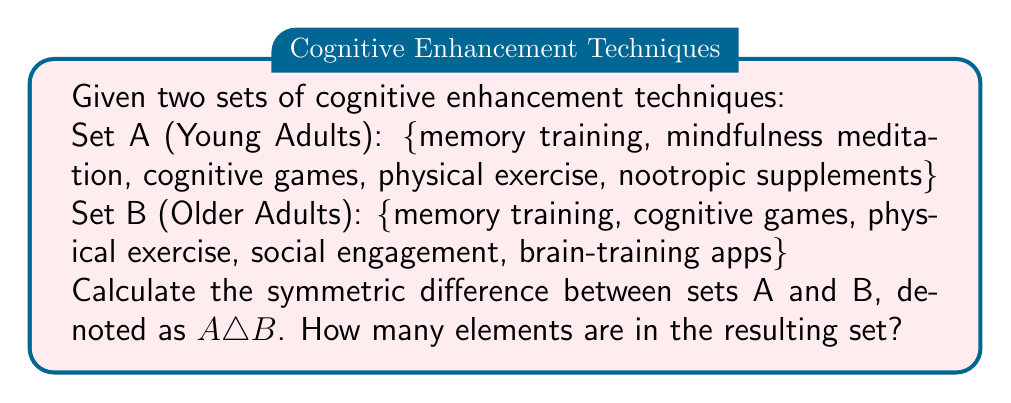Can you answer this question? To solve this problem, we need to follow these steps:

1. Understand the concept of symmetric difference:
   The symmetric difference of two sets A and B, denoted as $A \triangle B$, is the set of elements that are in either A or B, but not in both.

2. Mathematically, we can express this as:
   $A \triangle B = (A \setminus B) \cup (B \setminus A)$
   where $\setminus$ denotes set difference.

3. Identify the elements unique to each set:
   - Elements in A but not in B: {mindfulness meditation, nootropic supplements}
   - Elements in B but not in A: {social engagement, brain-training apps}

4. Combine these unique elements:
   $A \triangle B = \text{\{mindfulness meditation, nootropic supplements, social engagement, brain-training apps\}}$

5. Count the number of elements in the resulting set:
   $|A \triangle B| = 4$

Therefore, the symmetric difference between sets A and B contains 4 elements.
Answer: $|A \triangle B| = 4$ 